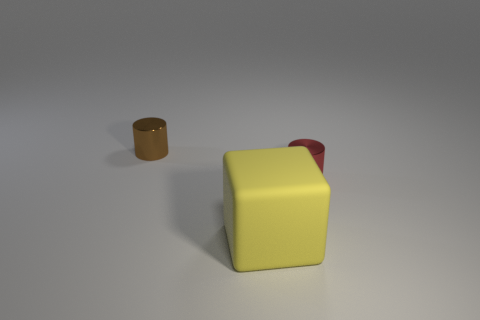Subtract all blue cubes. Subtract all yellow cylinders. How many cubes are left? 1 Add 3 small spheres. How many objects exist? 6 Subtract all cylinders. How many objects are left? 1 Add 2 small green shiny cylinders. How many small green shiny cylinders exist? 2 Subtract 0 green spheres. How many objects are left? 3 Subtract all balls. Subtract all brown objects. How many objects are left? 2 Add 2 metallic objects. How many metallic objects are left? 4 